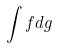<formula> <loc_0><loc_0><loc_500><loc_500>\int f d g</formula> 